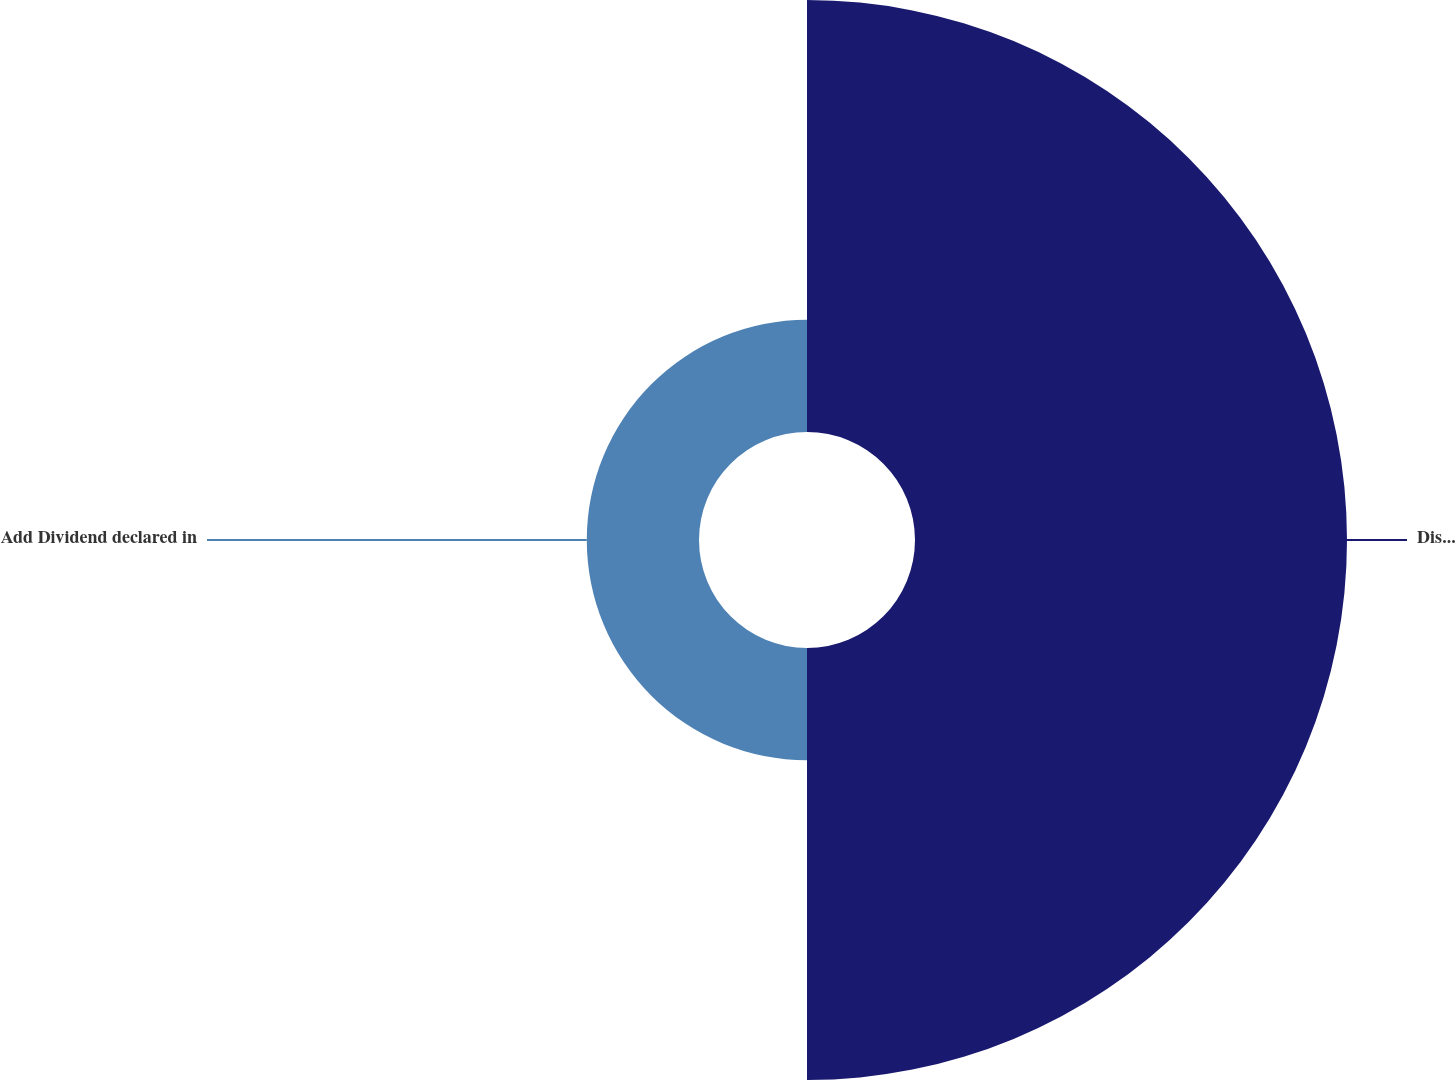<chart> <loc_0><loc_0><loc_500><loc_500><pie_chart><fcel>Distribution reportedfor<fcel>Add Dividend declared in<nl><fcel>79.38%<fcel>20.62%<nl></chart> 